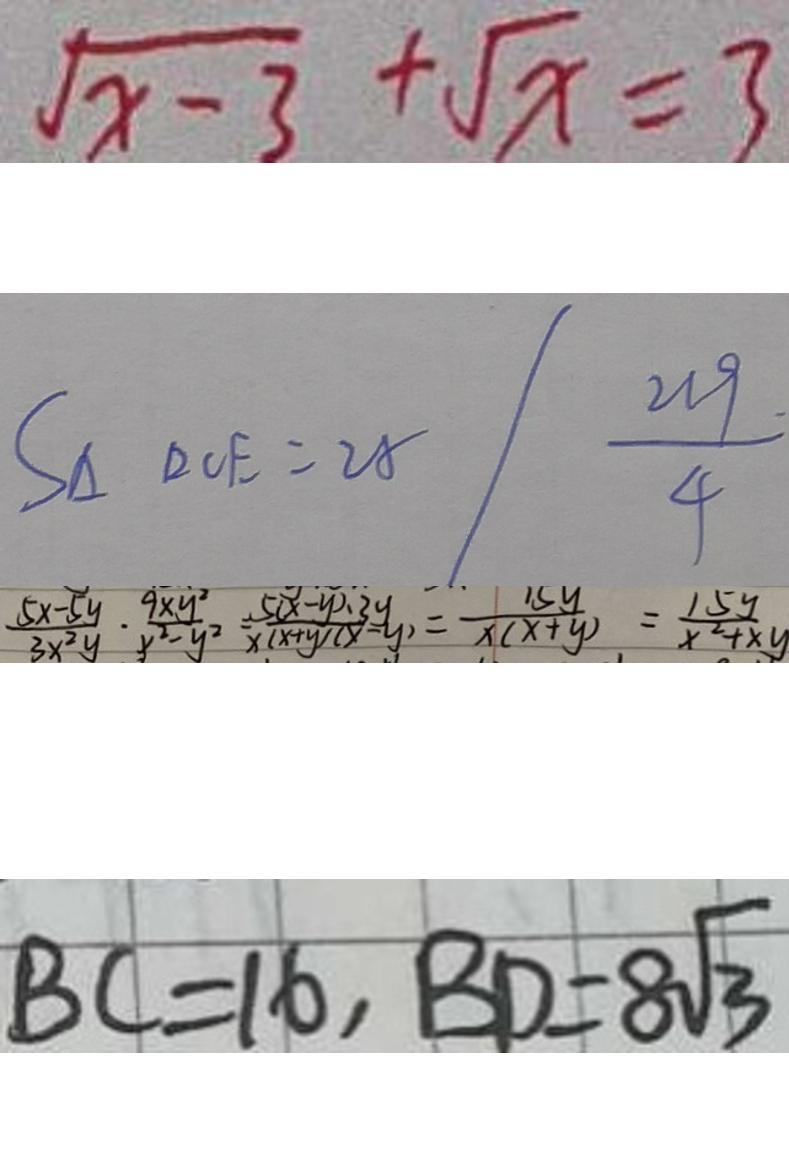Convert formula to latex. <formula><loc_0><loc_0><loc_500><loc_500>\sqrt { x - 3 } + \sqrt { x } = 3 
 S _ { \Delta } D C E = 2 8 / \frac { 2 1 9 . } { 4 } 
 \frac { 5 x - 5 y } { 3 x ^ { 2 } y } \cdot \frac { 9 x y ^ { 2 } } { y ^ { 2 } - y ^ { 2 } } \frac { 5 ( x - y ) \cdot 3 y } { x ( x + y ) ( x - y ) } = \frac { 1 5 y } { x ( x + y ) } = \frac { 1 5 y } { x ^ { 2 } + x y } 
 B C = 1 6 , B D = 8 \sqrt { 3 }</formula> 